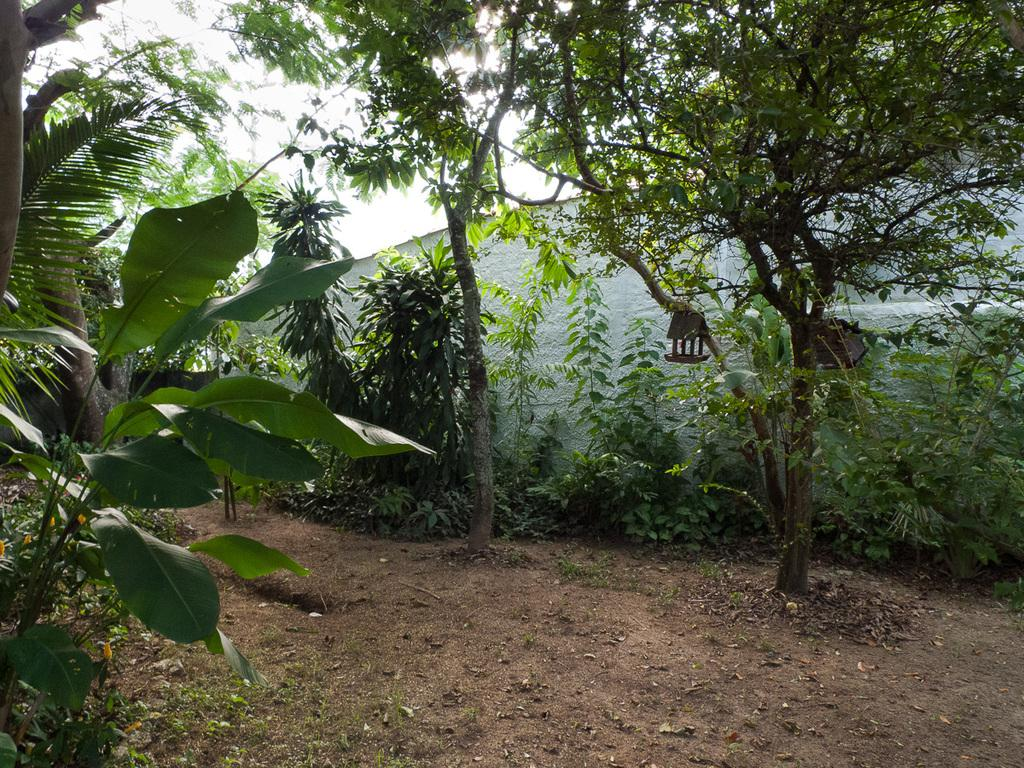What type of plants can be seen in the image? There are plants with flowers in the image in the image. What other natural elements are present in the image? There are trees in the image. What can be seen beneath the plants and trees? The ground is visible in the image. What is the background of the image composed of? There is a wall and the sky visible in the image. Can you see your mom swimming in the ocean in the image? There is no ocean or your mom present in the image; it features plants, trees, the ground, a wall, and the sky. 